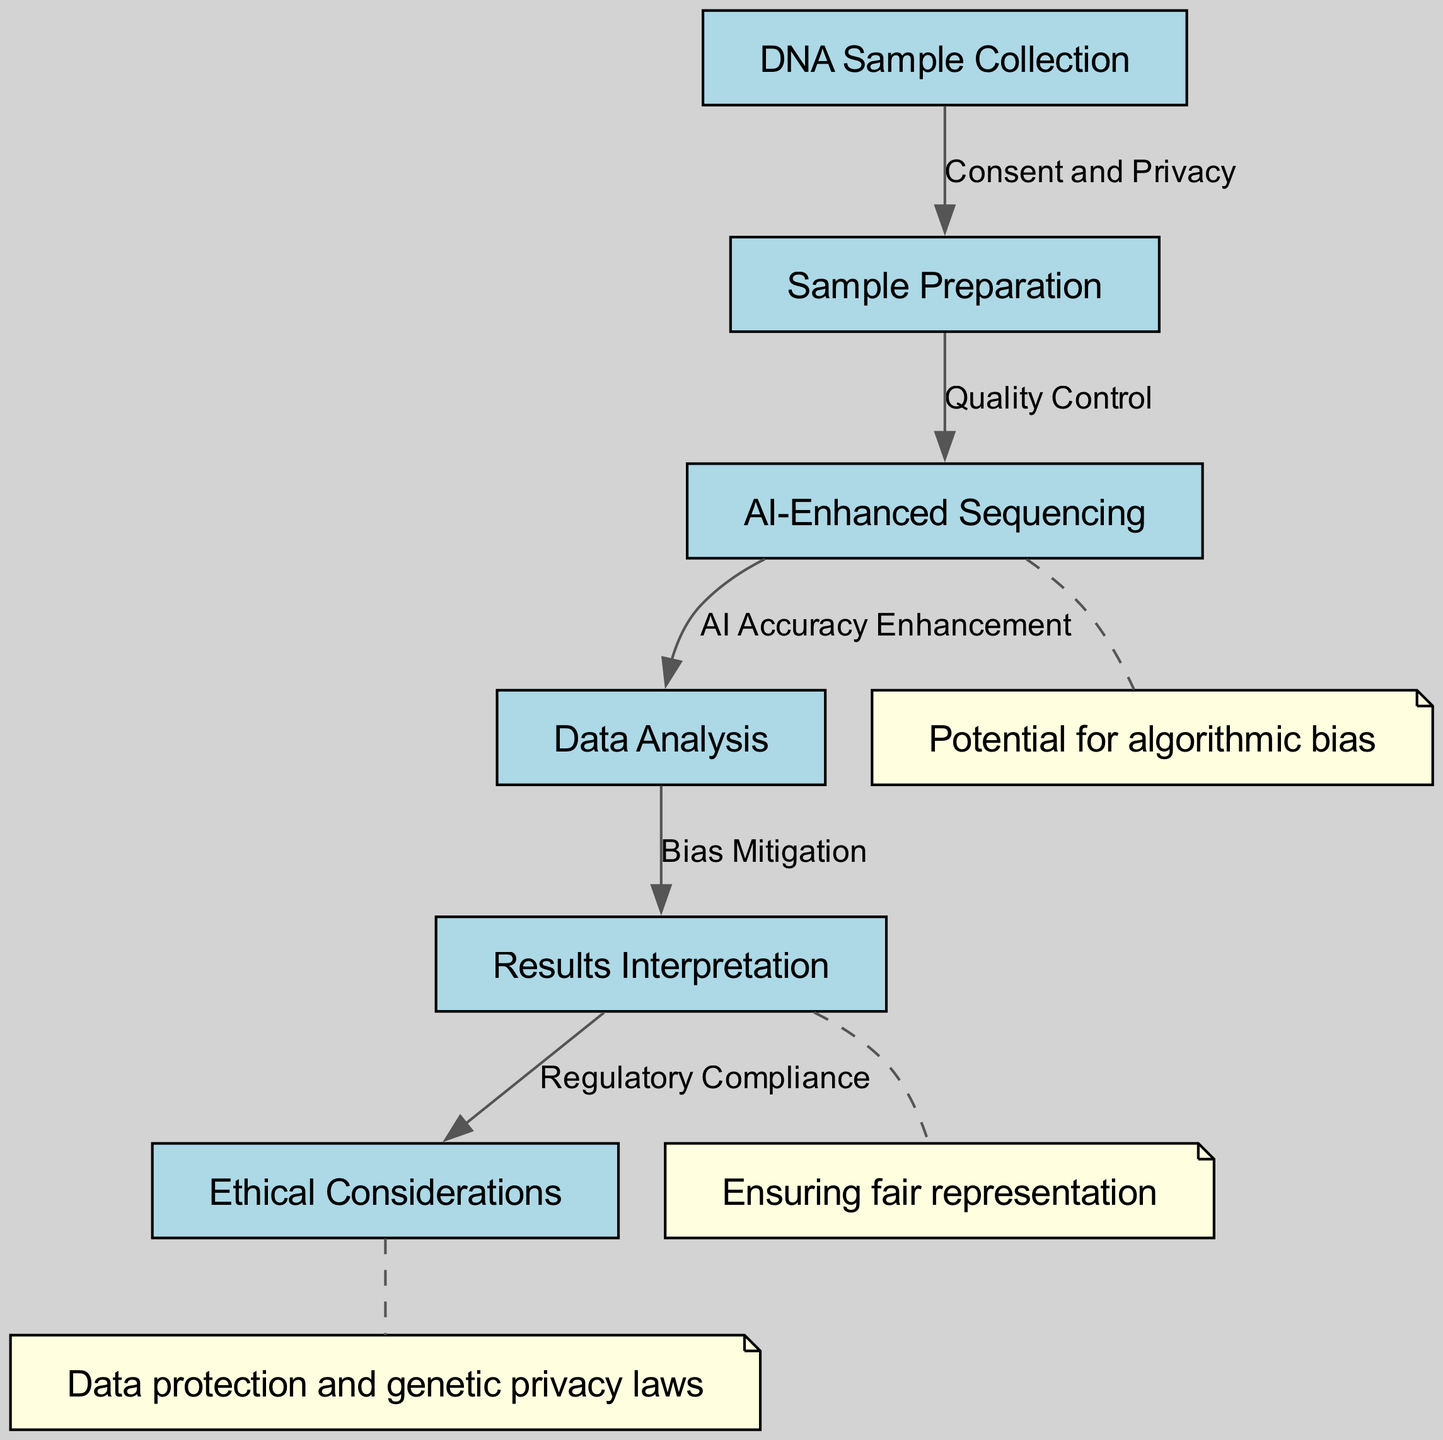What is the first step in the DNA sequencing process? The diagram shows that the first node is "DNA Sample Collection," indicating that this is the initial step in the process.
Answer: DNA Sample Collection How many nodes are there in the diagram? By counting the nodes listed in the data, we find there are a total of 6 nodes.
Answer: 6 What is the relationship between "Sample Preparation" and "AI-Enhanced Sequencing"? The diagram indicates that the edge connecting "Sample Preparation" to "AI-Enhanced Sequencing" is labeled "Quality Control," showing the direct relationship in the sequencing process.
Answer: Quality Control What ethical consideration is related to the final step of the process? The diagram connects the final node "Results Interpretation" to "Ethical Considerations" by the label "Regulatory Compliance," which suggests that regulations must be adhered to in the final interpretation stage.
Answer: Regulatory Compliance What potential issue is highlighted in the "AI-Enhanced Sequencing"? The annotation on the node "AI-Enhanced Sequencing" mentions the "Potential for algorithmic bias," which indicates a significant concern related to the use of AI in this stage.
Answer: Potential for algorithmic bias What does the edge labeled "Bias Mitigation" connect? The edge labeled "Bias Mitigation" connects the nodes "Data Analysis" and "Results Interpretation," indicating the process of addressing bias before interpreting results.
Answer: Data Analysis -> Results Interpretation What is the main focus of the annotation on the "Results Interpretation" node? The annotation states "Ensuring fair representation," which focuses on the importance of fairness and inclusivity during the interpretation of results.
Answer: Ensuring fair representation What is the label for the relationship between "DNA Sample Collection" and "Sample Preparation"? The edge between "DNA Sample Collection" and "Sample Preparation" is labeled "Consent and Privacy," indicating a key aspect of the initial step.
Answer: Consent and Privacy 